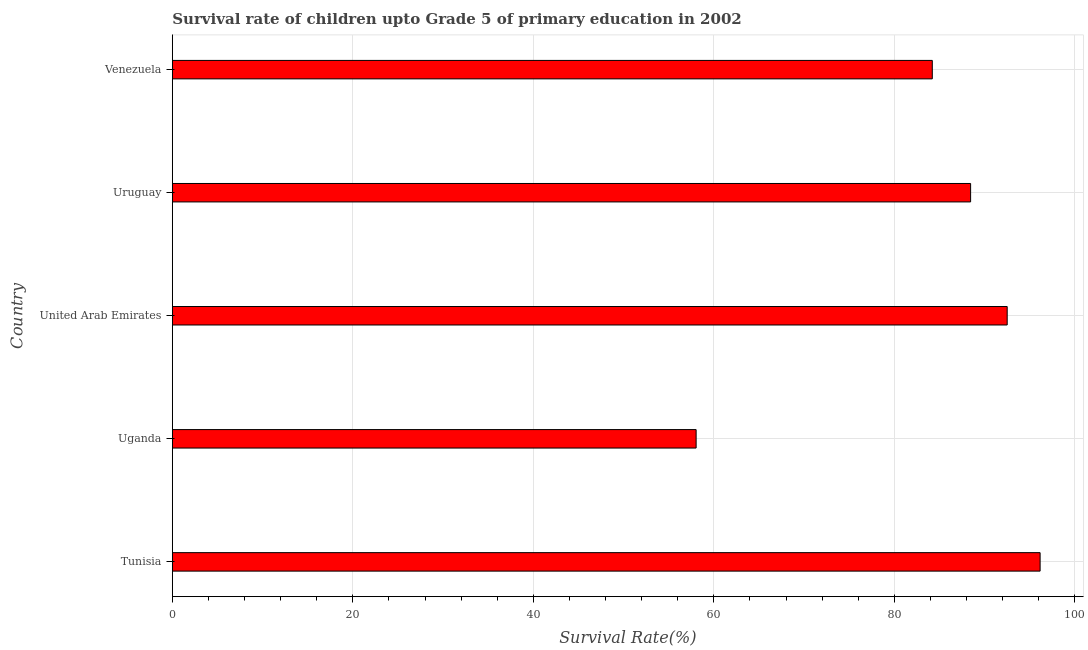Does the graph contain any zero values?
Your response must be concise. No. What is the title of the graph?
Offer a terse response. Survival rate of children upto Grade 5 of primary education in 2002 . What is the label or title of the X-axis?
Your answer should be compact. Survival Rate(%). What is the label or title of the Y-axis?
Ensure brevity in your answer.  Country. What is the survival rate in Venezuela?
Offer a very short reply. 84.21. Across all countries, what is the maximum survival rate?
Your answer should be compact. 96.15. Across all countries, what is the minimum survival rate?
Your answer should be very brief. 58.04. In which country was the survival rate maximum?
Ensure brevity in your answer.  Tunisia. In which country was the survival rate minimum?
Provide a short and direct response. Uganda. What is the sum of the survival rate?
Ensure brevity in your answer.  419.36. What is the difference between the survival rate in Uganda and Uruguay?
Give a very brief answer. -30.42. What is the average survival rate per country?
Your answer should be very brief. 83.87. What is the median survival rate?
Offer a terse response. 88.45. What is the ratio of the survival rate in Uganda to that in Uruguay?
Keep it short and to the point. 0.66. Is the survival rate in Tunisia less than that in Venezuela?
Keep it short and to the point. No. Is the difference between the survival rate in Tunisia and Uganda greater than the difference between any two countries?
Offer a very short reply. Yes. What is the difference between the highest and the second highest survival rate?
Ensure brevity in your answer.  3.65. Is the sum of the survival rate in Tunisia and United Arab Emirates greater than the maximum survival rate across all countries?
Provide a short and direct response. Yes. What is the difference between the highest and the lowest survival rate?
Make the answer very short. 38.12. In how many countries, is the survival rate greater than the average survival rate taken over all countries?
Give a very brief answer. 4. How many bars are there?
Offer a terse response. 5. Are all the bars in the graph horizontal?
Give a very brief answer. Yes. What is the Survival Rate(%) of Tunisia?
Your response must be concise. 96.15. What is the Survival Rate(%) of Uganda?
Keep it short and to the point. 58.04. What is the Survival Rate(%) in United Arab Emirates?
Your answer should be compact. 92.51. What is the Survival Rate(%) in Uruguay?
Keep it short and to the point. 88.45. What is the Survival Rate(%) in Venezuela?
Offer a very short reply. 84.21. What is the difference between the Survival Rate(%) in Tunisia and Uganda?
Provide a succinct answer. 38.12. What is the difference between the Survival Rate(%) in Tunisia and United Arab Emirates?
Keep it short and to the point. 3.65. What is the difference between the Survival Rate(%) in Tunisia and Uruguay?
Ensure brevity in your answer.  7.7. What is the difference between the Survival Rate(%) in Tunisia and Venezuela?
Keep it short and to the point. 11.95. What is the difference between the Survival Rate(%) in Uganda and United Arab Emirates?
Make the answer very short. -34.47. What is the difference between the Survival Rate(%) in Uganda and Uruguay?
Your response must be concise. -30.42. What is the difference between the Survival Rate(%) in Uganda and Venezuela?
Your answer should be very brief. -26.17. What is the difference between the Survival Rate(%) in United Arab Emirates and Uruguay?
Give a very brief answer. 4.05. What is the difference between the Survival Rate(%) in United Arab Emirates and Venezuela?
Provide a short and direct response. 8.3. What is the difference between the Survival Rate(%) in Uruguay and Venezuela?
Give a very brief answer. 4.25. What is the ratio of the Survival Rate(%) in Tunisia to that in Uganda?
Give a very brief answer. 1.66. What is the ratio of the Survival Rate(%) in Tunisia to that in United Arab Emirates?
Offer a very short reply. 1.04. What is the ratio of the Survival Rate(%) in Tunisia to that in Uruguay?
Provide a short and direct response. 1.09. What is the ratio of the Survival Rate(%) in Tunisia to that in Venezuela?
Give a very brief answer. 1.14. What is the ratio of the Survival Rate(%) in Uganda to that in United Arab Emirates?
Your answer should be very brief. 0.63. What is the ratio of the Survival Rate(%) in Uganda to that in Uruguay?
Provide a succinct answer. 0.66. What is the ratio of the Survival Rate(%) in Uganda to that in Venezuela?
Keep it short and to the point. 0.69. What is the ratio of the Survival Rate(%) in United Arab Emirates to that in Uruguay?
Your answer should be compact. 1.05. What is the ratio of the Survival Rate(%) in United Arab Emirates to that in Venezuela?
Offer a terse response. 1.1. 